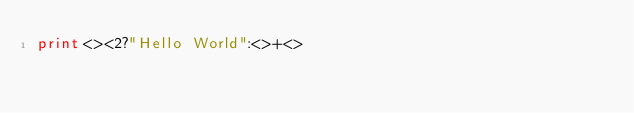Convert code to text. <code><loc_0><loc_0><loc_500><loc_500><_Perl_>print<><2?"Hello World":<>+<></code> 